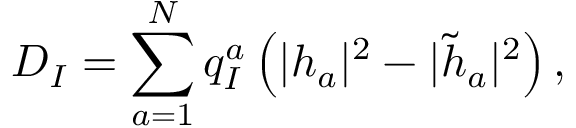<formula> <loc_0><loc_0><loc_500><loc_500>D _ { I } = \sum _ { a = 1 } ^ { N } q _ { I } ^ { a } \left ( | h _ { a } | ^ { 2 } - | \tilde { h } _ { a } | ^ { 2 } \right ) ,</formula> 